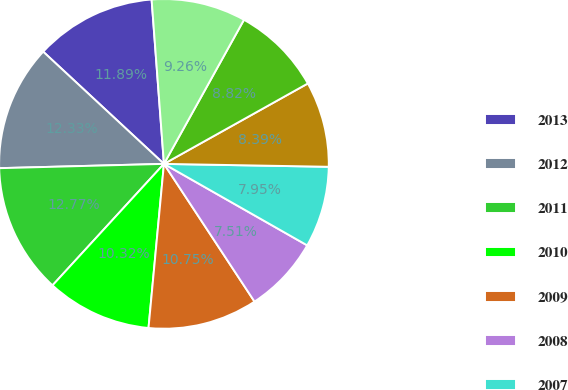<chart> <loc_0><loc_0><loc_500><loc_500><pie_chart><fcel>2013<fcel>2012<fcel>2011<fcel>2010<fcel>2009<fcel>2008<fcel>2007<fcel>2006<fcel>2005<fcel>2004<nl><fcel>11.89%<fcel>12.33%<fcel>12.77%<fcel>10.32%<fcel>10.75%<fcel>7.51%<fcel>7.95%<fcel>8.39%<fcel>8.82%<fcel>9.26%<nl></chart> 